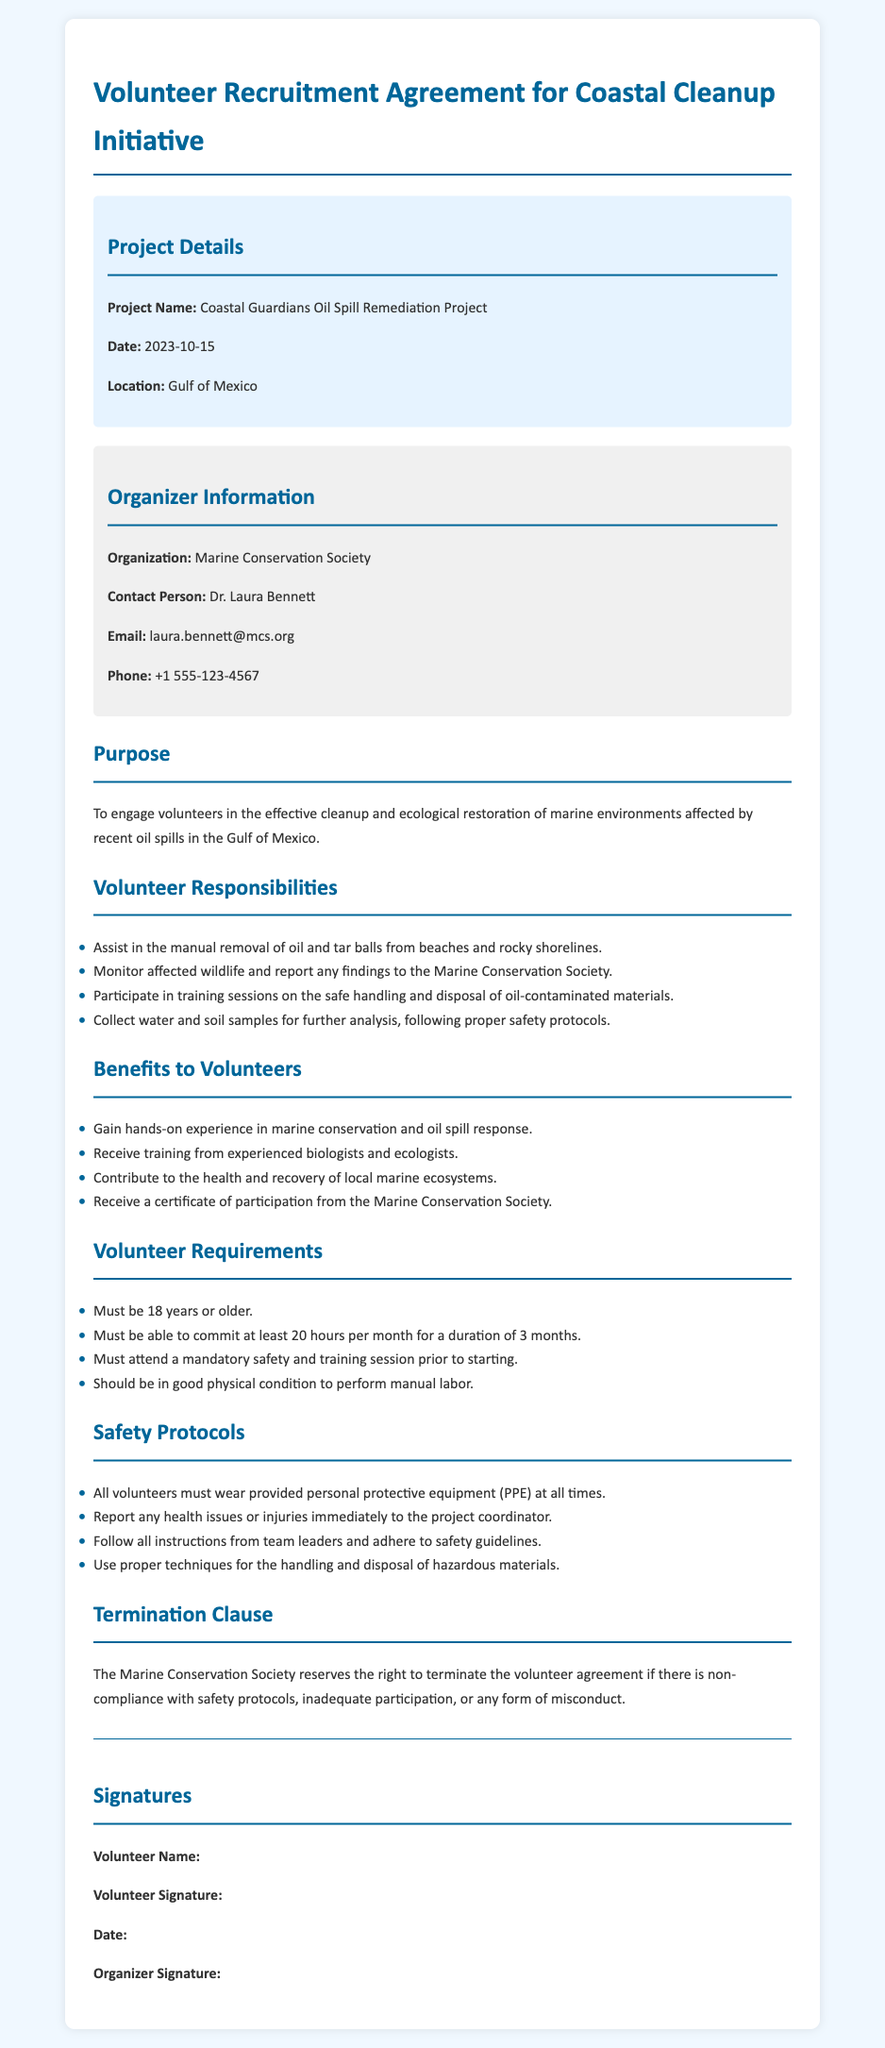what is the project name? The project name is listed in the project details section of the document.
Answer: Coastal Guardians Oil Spill Remediation Project who is the contact person for the initiative? The contact person is indicated in the organizer information section of the document.
Answer: Dr. Laura Bennett what is the location of the cleanup project? The location is specified in the project details section.
Answer: Gulf of Mexico how many hours per month must a volunteer commit? The requirement for volunteer hours is stated in the volunteer requirements section.
Answer: 20 hours what is the minimum age requirement for volunteers? The minimum age is mentioned in the volunteer requirements section.
Answer: 18 years what type of training will volunteers receive? The type of training provided is detailed in the benefits to volunteers section.
Answer: Training from experienced biologists and ecologists what can lead to the termination of the volunteer agreement? The reasons for termination are outlined in the termination clause section.
Answer: Non-compliance with safety protocols how many months is the commitment duration for volunteers? The commitment duration is specified in the volunteer requirements section.
Answer: 3 months what must volunteers wear at all times? This safety requirement is indicated in the safety protocols section.
Answer: Personal protective equipment (PPE) 